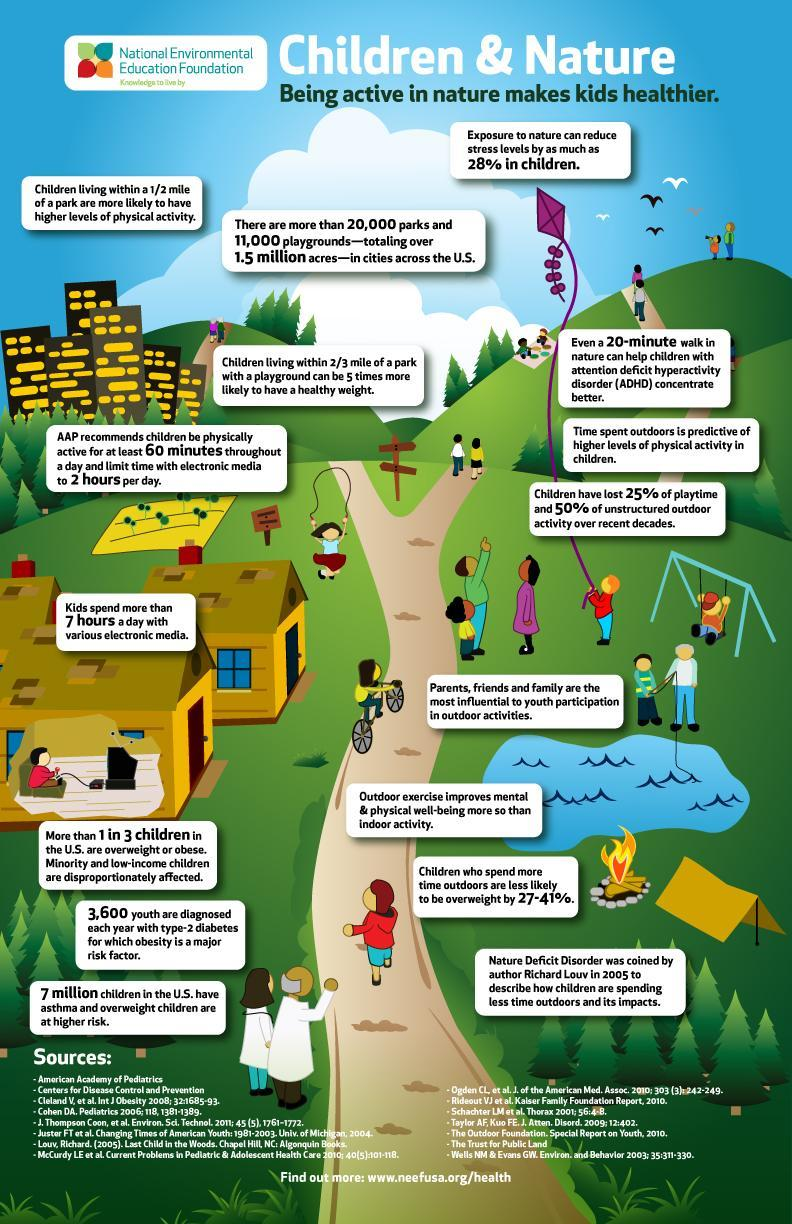What percentage of children in the U.S. are obese or overweight?
Answer the question with a short phrase. 33.33% How much more time do kids actually spend using electronic media compared to the recommendation form AAP? 5 hours What is the recommended time for kids to use electronic media per day according to AAP? 2 hours Who can influence youth to participate in outdoor activities? Parents,friends and family 